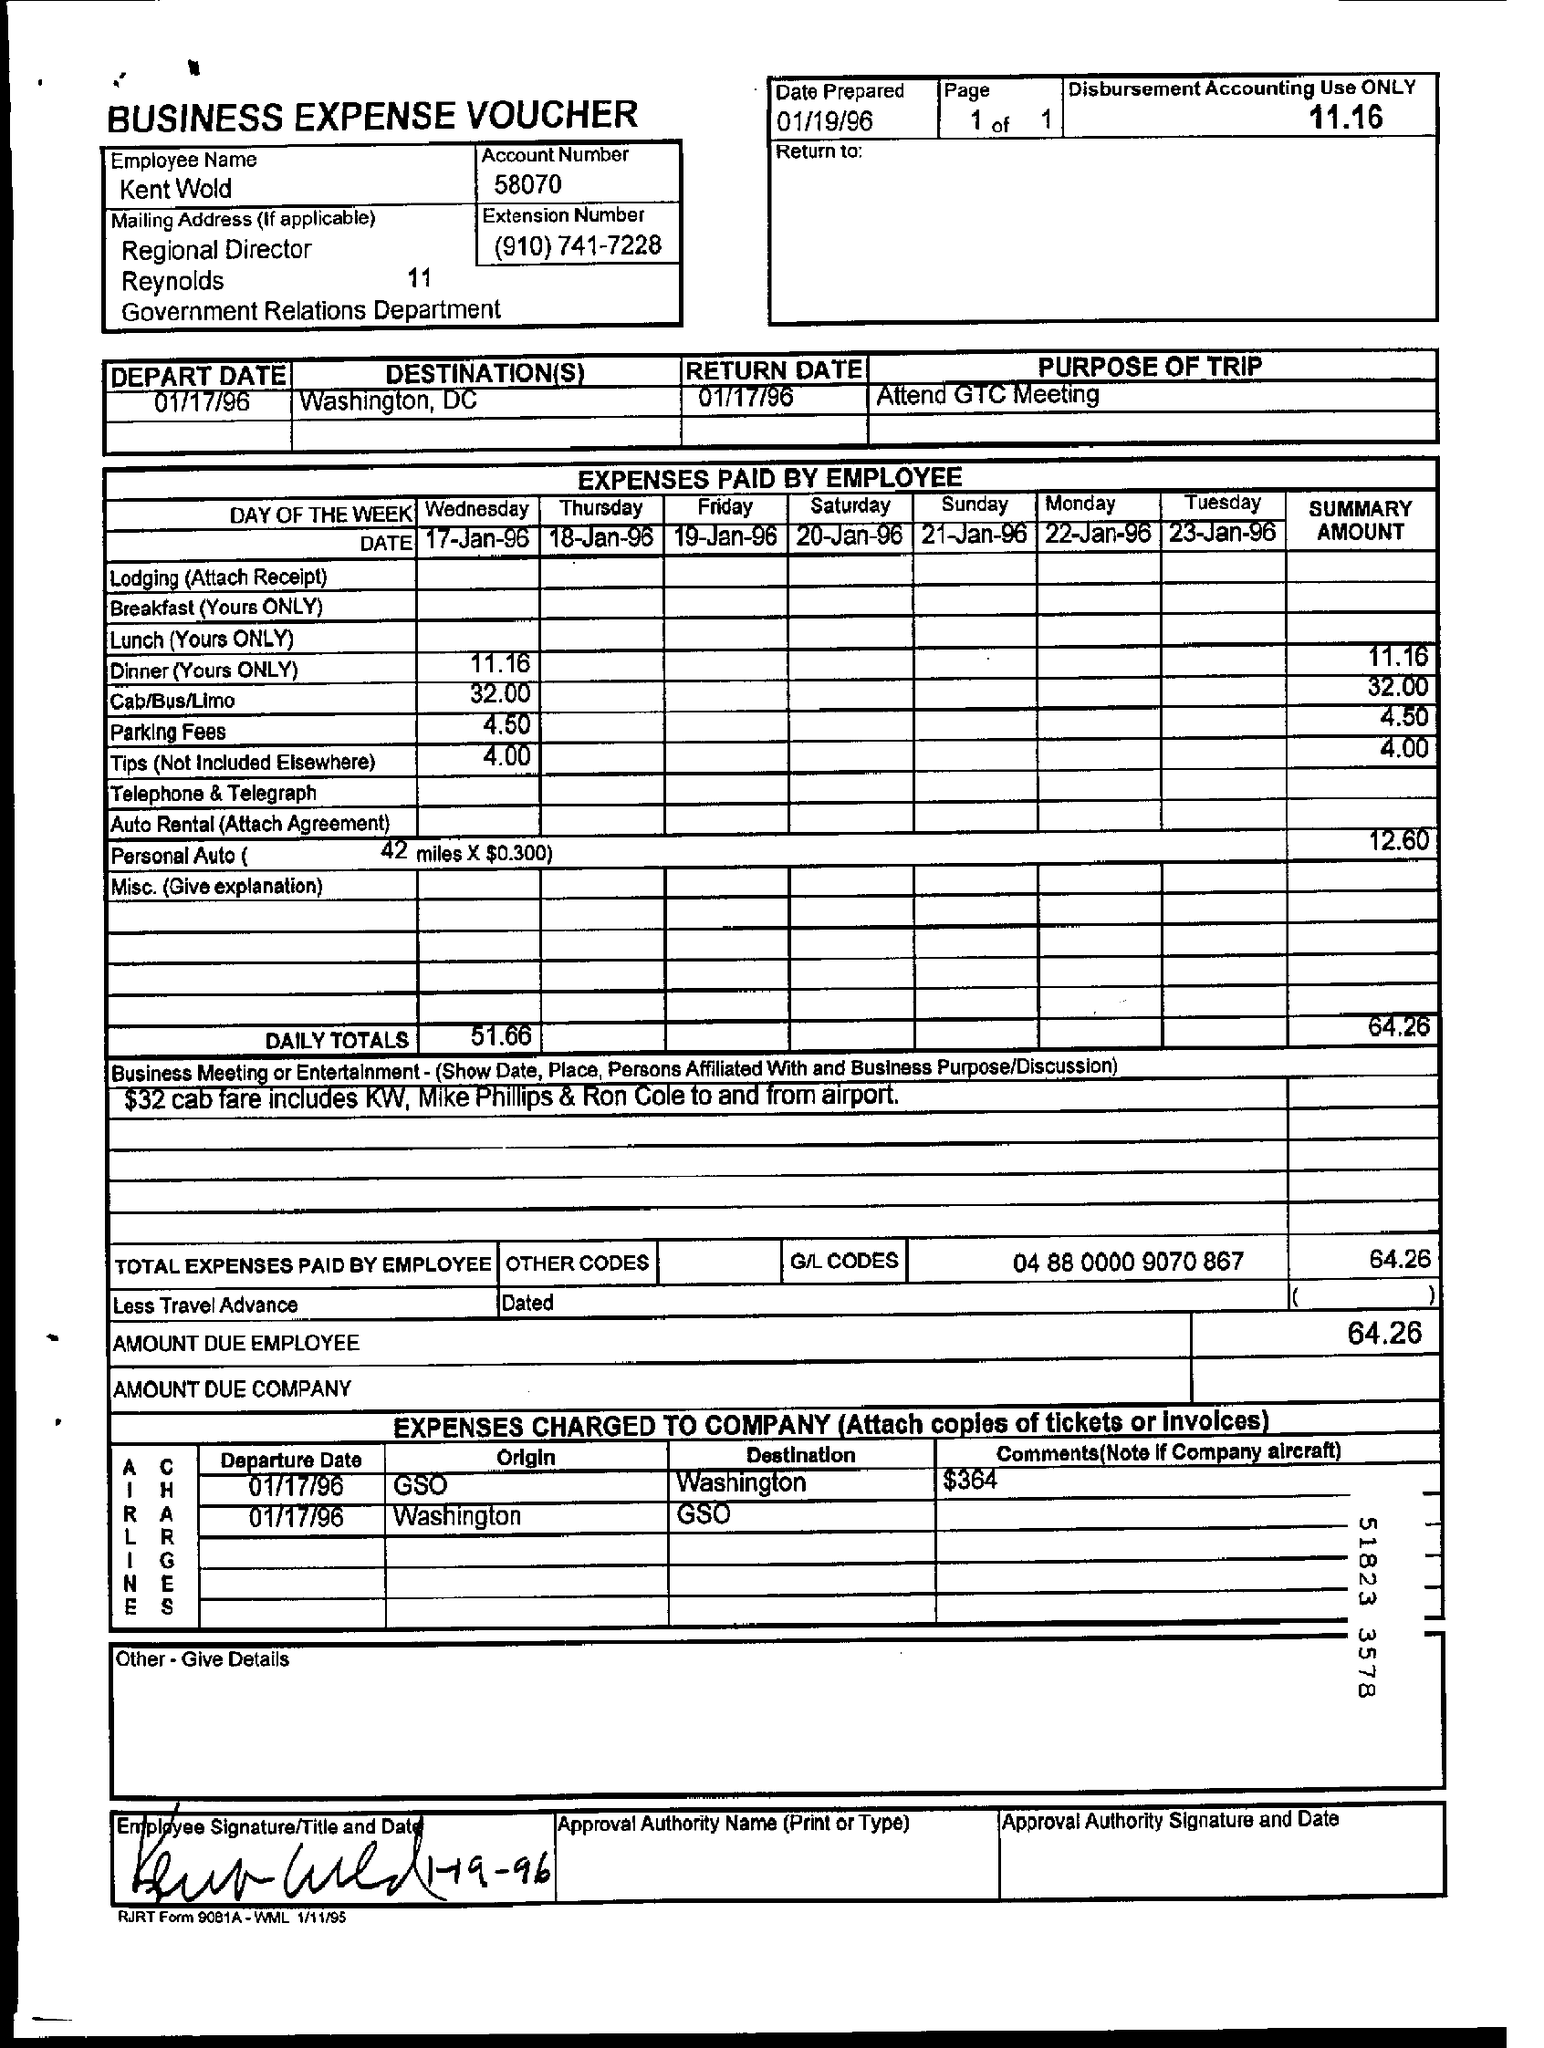Mention a couple of crucial points in this snapshot. The employee's name is Kent Wold. It is the intention of the trip to attend the GTC Meeting. The account number is 58070. This is a business expense voucher. The date prepared is January 19, 1996. 